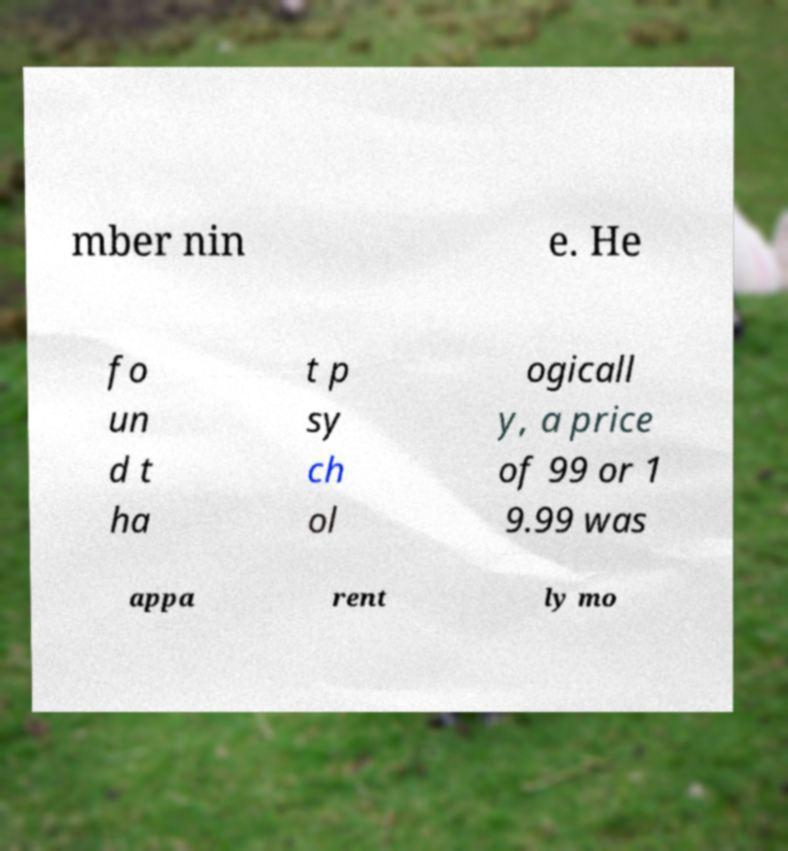Could you extract and type out the text from this image? mber nin e. He fo un d t ha t p sy ch ol ogicall y, a price of 99 or 1 9.99 was appa rent ly mo 